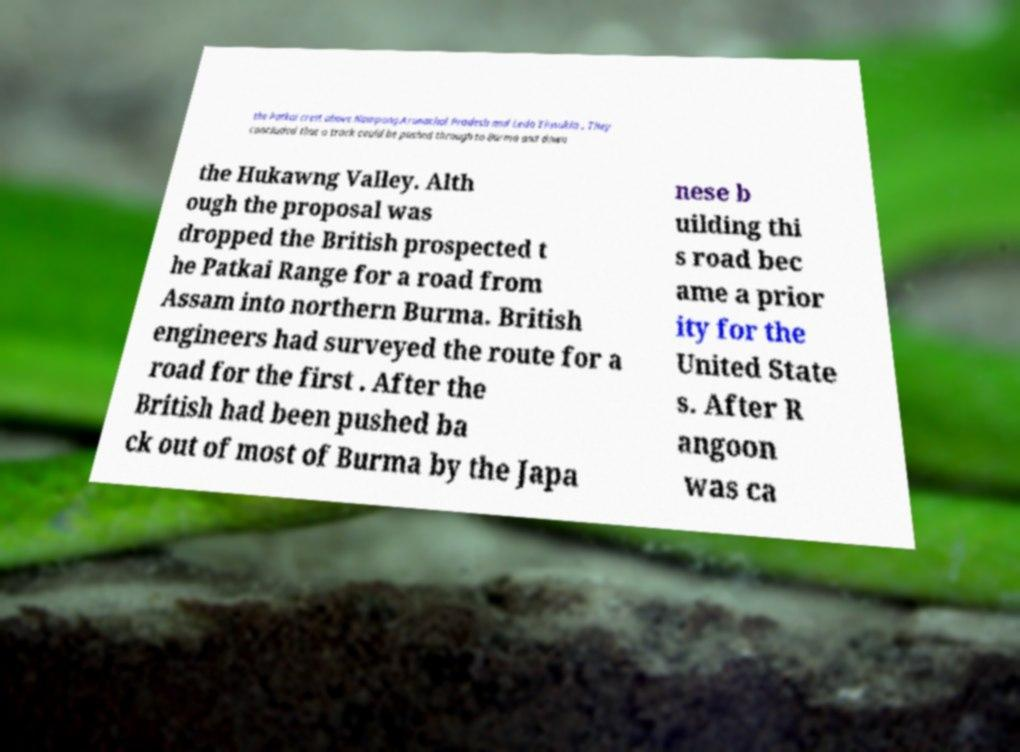I need the written content from this picture converted into text. Can you do that? the Patkai crest above Nampong Arunachal Pradesh and Ledo Tinsukia . They concluded that a track could be pushed through to Burma and down the Hukawng Valley. Alth ough the proposal was dropped the British prospected t he Patkai Range for a road from Assam into northern Burma. British engineers had surveyed the route for a road for the first . After the British had been pushed ba ck out of most of Burma by the Japa nese b uilding thi s road bec ame a prior ity for the United State s. After R angoon was ca 